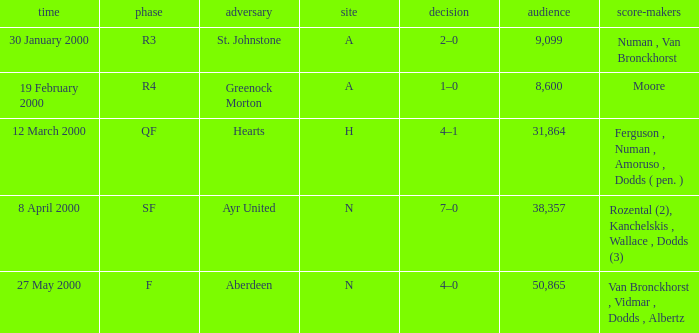What venue was on 27 May 2000? N. 